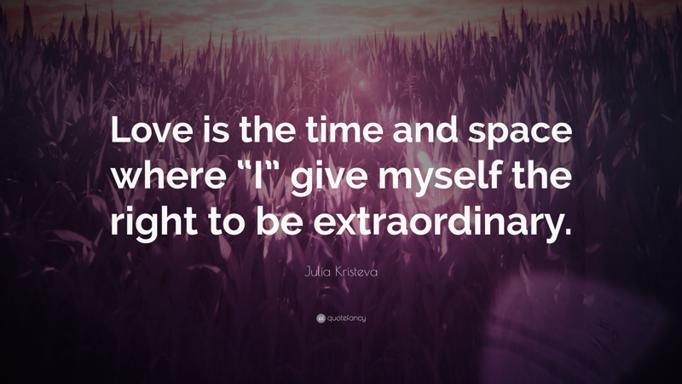Please describe any additional graphical elements you can see in this image. The image prominently displays a dense field of grass with its tips highlighted by the purple and pink hues of the twilight sky. The color gradient in the background suggests that the image was captured during sunrise or sunset, which adds a time element to the scene, subtly linking back to the quote about time and space. 